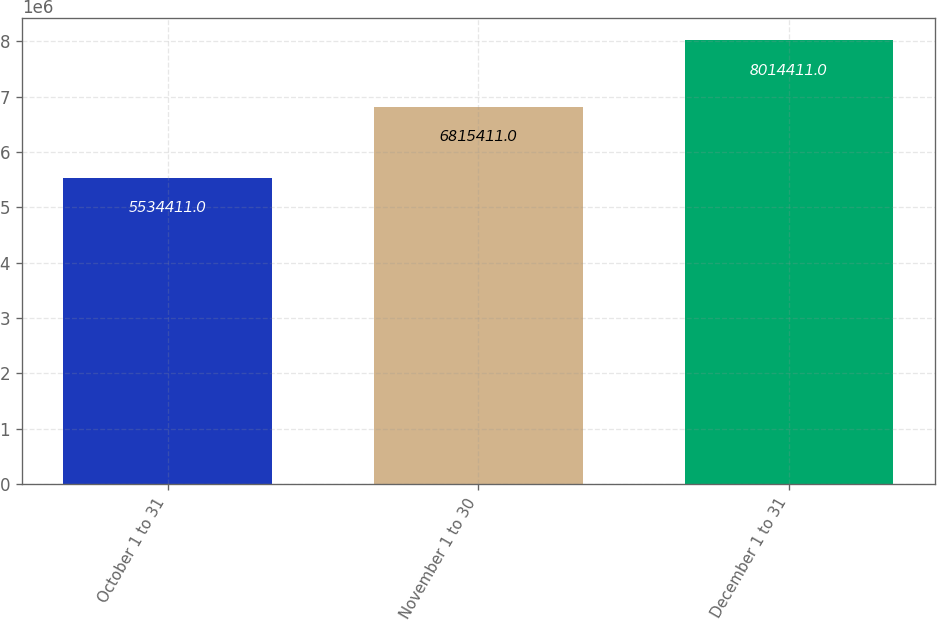Convert chart. <chart><loc_0><loc_0><loc_500><loc_500><bar_chart><fcel>October 1 to 31<fcel>November 1 to 30<fcel>December 1 to 31<nl><fcel>5.53441e+06<fcel>6.81541e+06<fcel>8.01441e+06<nl></chart> 